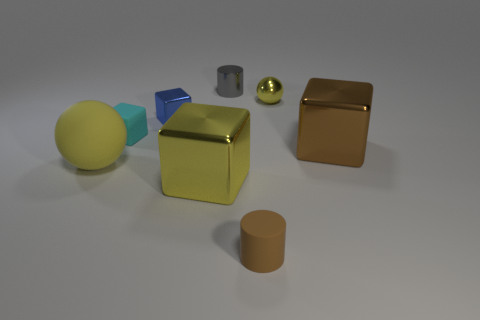Are there fewer yellow things that are in front of the metallic ball than small blue things?
Provide a succinct answer. No. What shape is the matte object that is the same size as the cyan matte cube?
Your answer should be very brief. Cylinder. How many other things are the same color as the small shiny ball?
Offer a terse response. 2. Does the shiny cylinder have the same size as the blue block?
Ensure brevity in your answer.  Yes. What number of things are either large brown objects or metal blocks to the left of the small yellow sphere?
Ensure brevity in your answer.  3. Are there fewer small yellow balls to the right of the big brown block than tiny yellow metal spheres that are left of the yellow rubber object?
Your response must be concise. No. How many other objects are there of the same material as the big yellow cube?
Offer a terse response. 4. Do the metal block in front of the big brown shiny cube and the large rubber sphere have the same color?
Offer a very short reply. Yes. Are there any tiny cylinders to the right of the large block that is on the left side of the gray cylinder?
Ensure brevity in your answer.  Yes. There is a cube that is behind the large brown thing and on the right side of the small cyan rubber thing; what is its material?
Keep it short and to the point. Metal. 